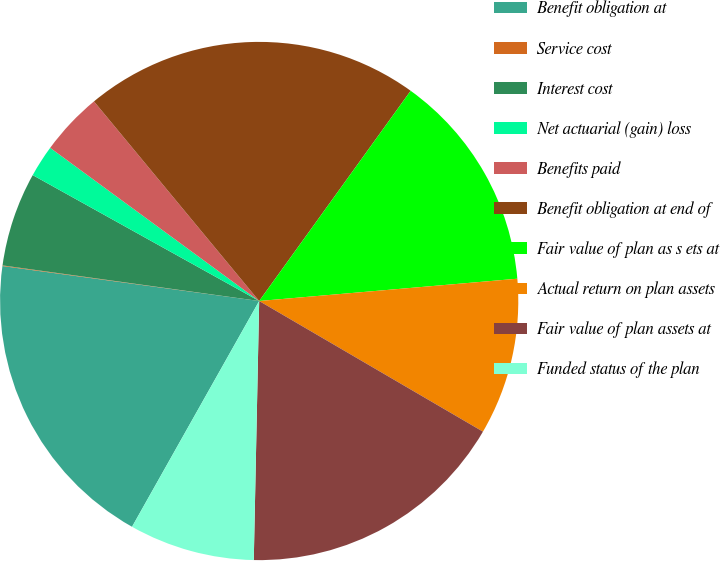Convert chart. <chart><loc_0><loc_0><loc_500><loc_500><pie_chart><fcel>Benefit obligation at<fcel>Service cost<fcel>Interest cost<fcel>Net actuarial (gain) loss<fcel>Benefits paid<fcel>Benefit obligation at end of<fcel>Fair value of plan as s ets at<fcel>Actual return on plan assets<fcel>Fair value of plan assets at<fcel>Funded status of the plan<nl><fcel>18.99%<fcel>0.04%<fcel>5.88%<fcel>1.99%<fcel>3.93%<fcel>20.94%<fcel>13.69%<fcel>9.78%<fcel>16.92%<fcel>7.83%<nl></chart> 